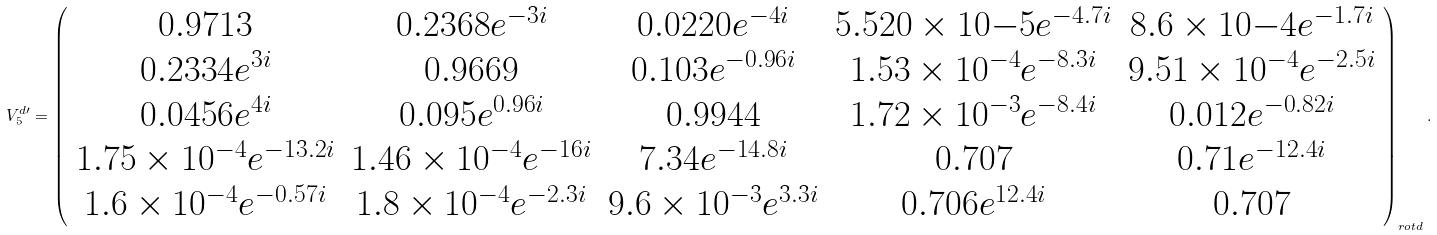<formula> <loc_0><loc_0><loc_500><loc_500>V _ { 5 } ^ { d \prime } = \left ( \begin{array} { c c c c c } 0 . 9 7 1 3 & 0 . 2 3 6 8 e ^ { - 3 i } & 0 . 0 2 2 0 e ^ { - 4 i } & 5 . 5 2 0 \times 1 0 { - 5 } e ^ { - 4 . 7 i } & 8 . 6 \times 1 0 { - 4 } e ^ { - 1 . 7 i } \\ 0 . 2 3 3 4 e ^ { 3 i } & 0 . 9 6 6 9 & 0 . 1 0 3 e ^ { - 0 . 9 6 i } & 1 . 5 3 \times 1 0 ^ { - 4 } e ^ { - 8 . 3 i } & 9 . 5 1 \times 1 0 ^ { - 4 } e ^ { - 2 . 5 i } \\ 0 . 0 4 5 6 e ^ { 4 i } & 0 . 0 9 5 e ^ { 0 . 9 6 i } & 0 . 9 9 4 4 & 1 . 7 2 \times 1 0 ^ { - 3 } e ^ { - 8 . 4 i } & 0 . 0 1 2 e ^ { - 0 . 8 2 i } \\ 1 . 7 5 \times 1 0 ^ { - 4 } e ^ { - 1 3 . 2 i } & 1 . 4 6 \times 1 0 ^ { - 4 } e ^ { - 1 6 i } & 7 . 3 4 e ^ { - 1 4 . 8 i } & 0 . 7 0 7 & 0 . 7 1 e ^ { - 1 2 . 4 i } \\ 1 . 6 \times 1 0 ^ { - 4 } e ^ { - 0 . 5 7 i } & 1 . 8 \times 1 0 ^ { - 4 } e ^ { - 2 . 3 i } & 9 . 6 \times 1 0 ^ { - 3 } e ^ { 3 . 3 i } & 0 . 7 0 6 e ^ { 1 2 . 4 i } & 0 . 7 0 7 \end{array} \right ) _ { r o t d } .</formula> 